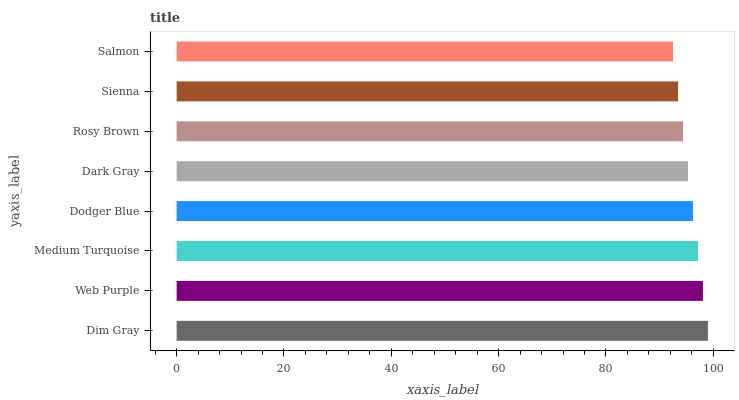Is Salmon the minimum?
Answer yes or no. Yes. Is Dim Gray the maximum?
Answer yes or no. Yes. Is Web Purple the minimum?
Answer yes or no. No. Is Web Purple the maximum?
Answer yes or no. No. Is Dim Gray greater than Web Purple?
Answer yes or no. Yes. Is Web Purple less than Dim Gray?
Answer yes or no. Yes. Is Web Purple greater than Dim Gray?
Answer yes or no. No. Is Dim Gray less than Web Purple?
Answer yes or no. No. Is Dodger Blue the high median?
Answer yes or no. Yes. Is Dark Gray the low median?
Answer yes or no. Yes. Is Web Purple the high median?
Answer yes or no. No. Is Sienna the low median?
Answer yes or no. No. 